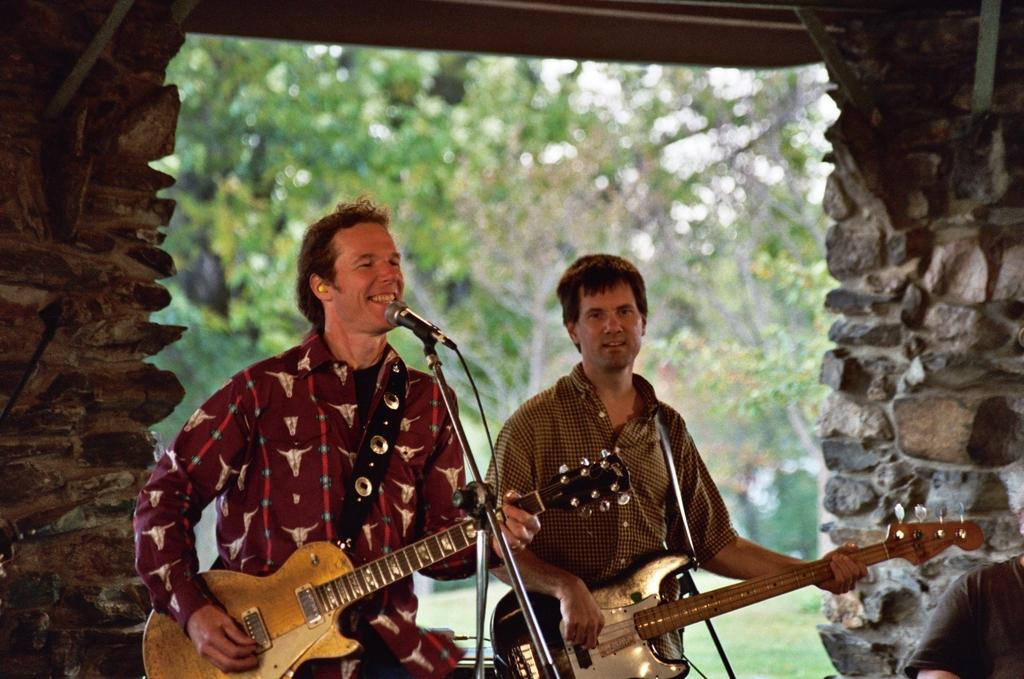How many people are in the image? There are two persons in the image. What are the persons doing in the image? The persons are holding a guitar and singing. What object can be seen in front of the persons? They are in front of a microphone. What can be seen in the background of the image? There is a wall, a tree, and the sky visible in the background of the image. What type of humor can be seen in the image? There is no humor present in the image; it features two people singing with a guitar and a microphone. What invention is being used by the persons in the image? The persons are using a guitar and a microphone, but there is no specific invention being showcased in the image. 